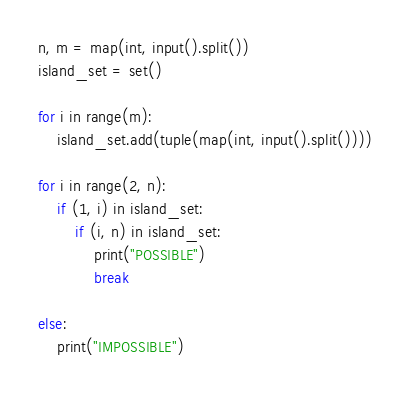Convert code to text. <code><loc_0><loc_0><loc_500><loc_500><_Python_>n, m = map(int, input().split())
island_set = set()

for i in range(m):
    island_set.add(tuple(map(int, input().split())))

for i in range(2, n):
    if (1, i) in island_set:
        if (i, n) in island_set:
            print("POSSIBLE")
            break

else:
    print("IMPOSSIBLE")
</code> 